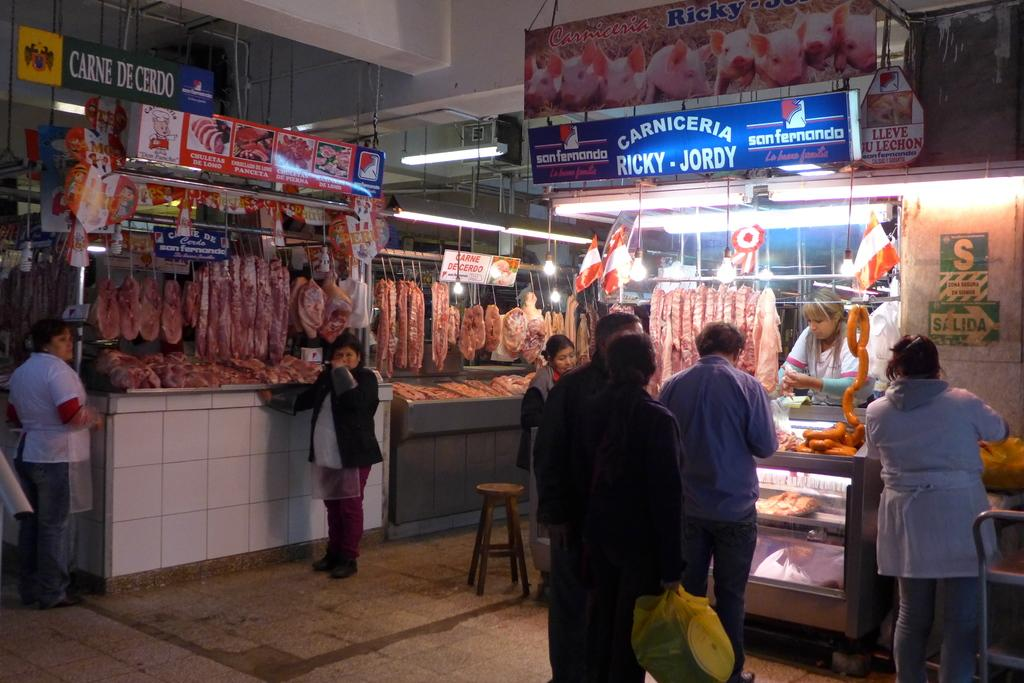What is the primary activity of the people in the image? The people in the image are on the ground, but the specific activity is not mentioned in the facts. What type of food can be seen in the image? There is meat visible in the image. What type of furniture is present in the image? There are stools in the image. What type of decorations are present in the image? There are flags and posters in the image. What type of signage is present in the image? There are name boards in the image. What type of lighting is present in the image? There is a light in the image. What type of structure is present in the image? There are walls in the image. Can you describe the unspecified objects in the image? The facts do not provide any details about the unspecified objects in the image. How does the cannon affect the attention of the people in the image? There is no cannon present in the image, so it cannot affect the attention of the people. What type of scale is used to weigh the meat in the image? There is no scale present in the image, so it cannot be used to weigh the meat. 